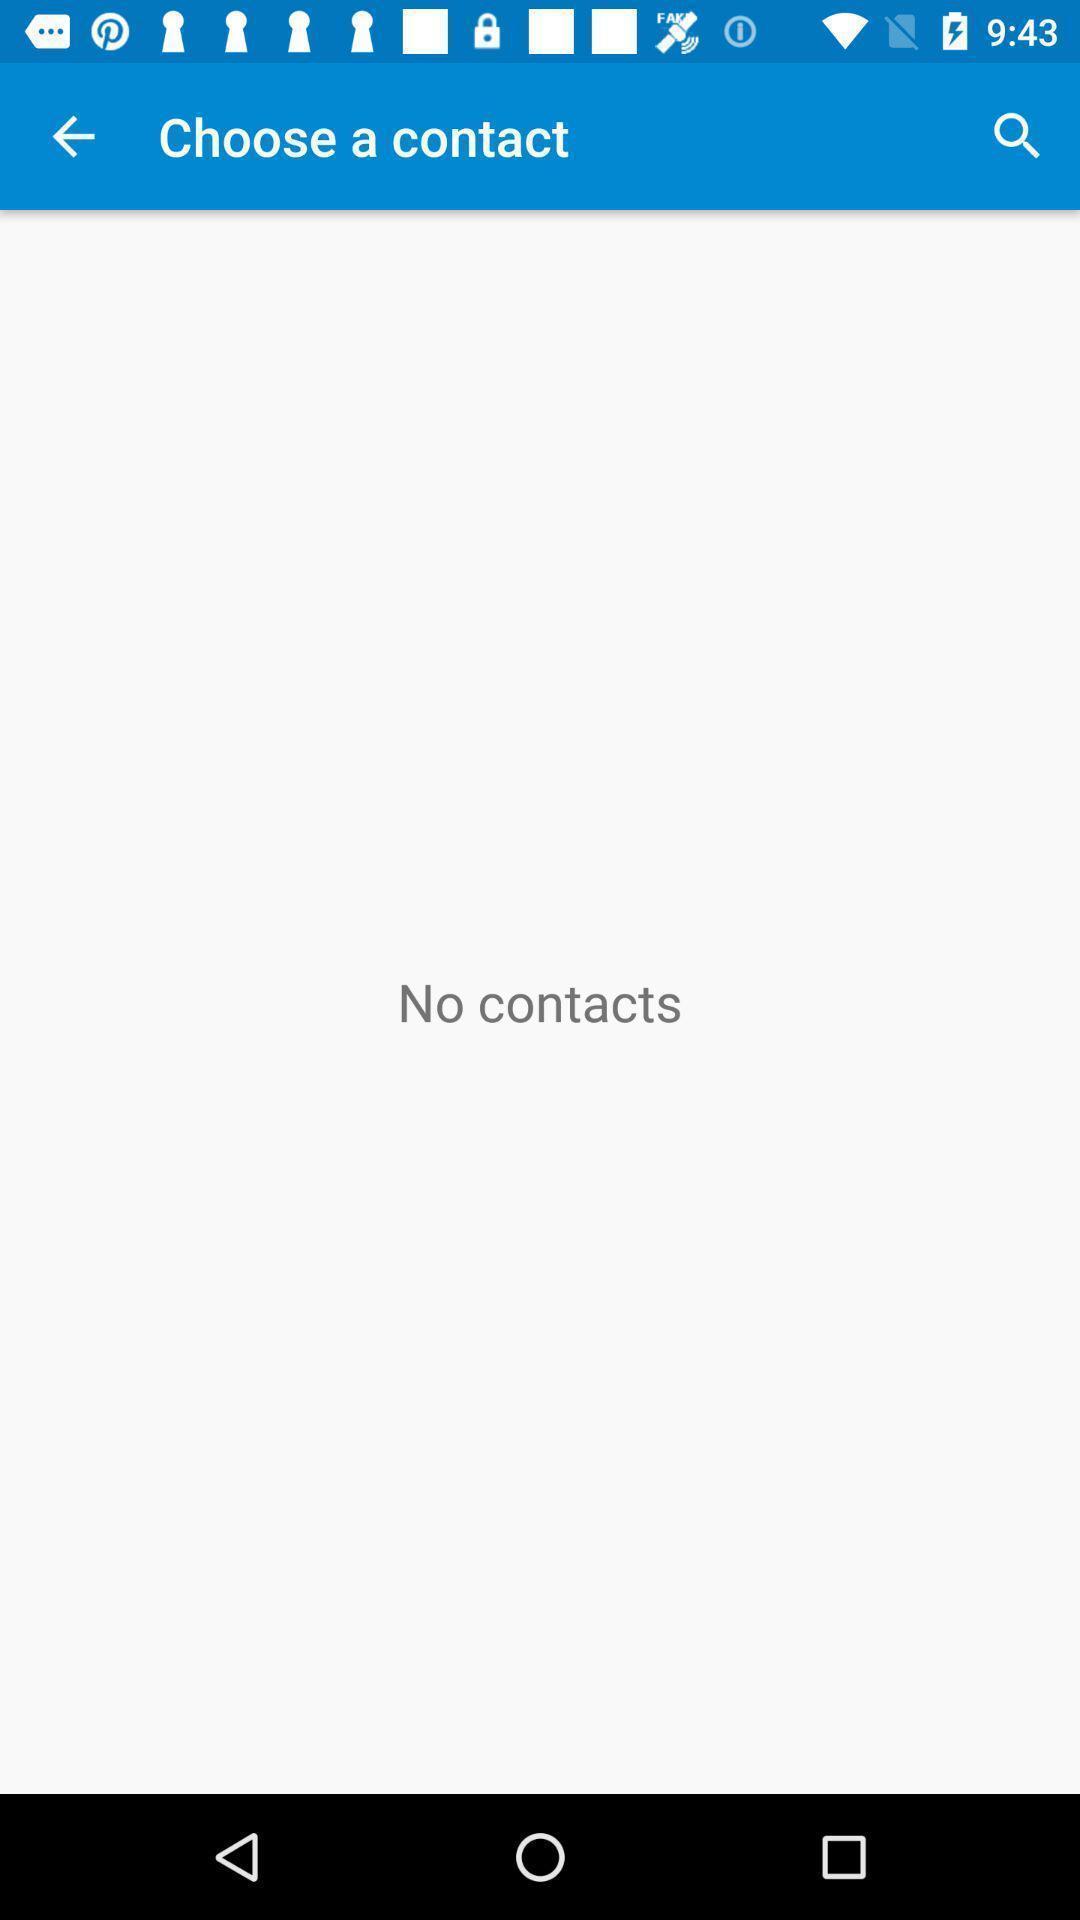Provide a textual representation of this image. Screen showing choose a contact option. 